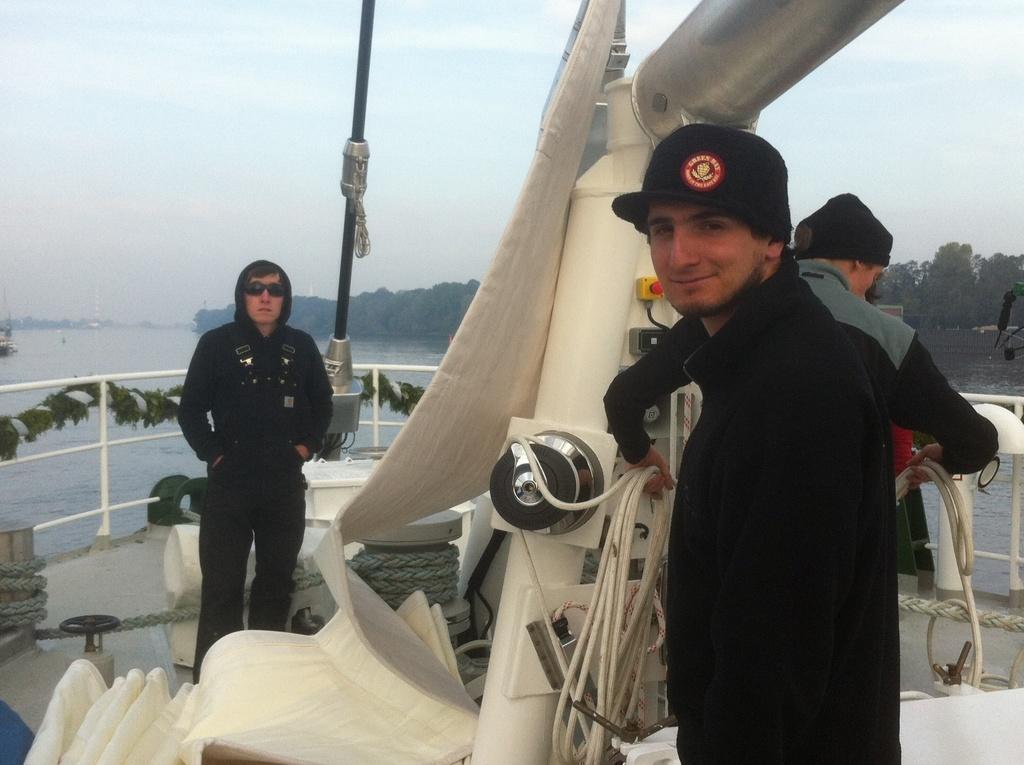Could you give a brief overview of what you see in this image? In this image, we can see persons wearing clothes. There is a machine in the middle of the image. There is a lake on the left side of the image. There are some trees in the middle of the image. There is a sky at the top of the image. 